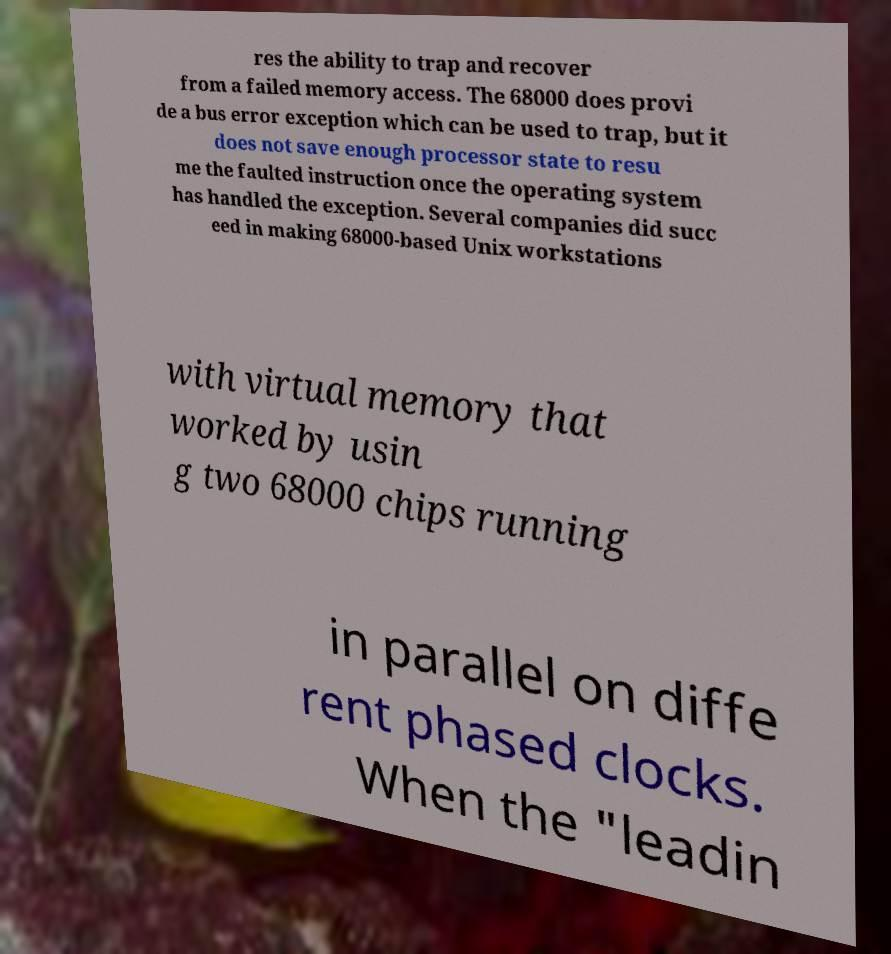Could you assist in decoding the text presented in this image and type it out clearly? res the ability to trap and recover from a failed memory access. The 68000 does provi de a bus error exception which can be used to trap, but it does not save enough processor state to resu me the faulted instruction once the operating system has handled the exception. Several companies did succ eed in making 68000-based Unix workstations with virtual memory that worked by usin g two 68000 chips running in parallel on diffe rent phased clocks. When the "leadin 